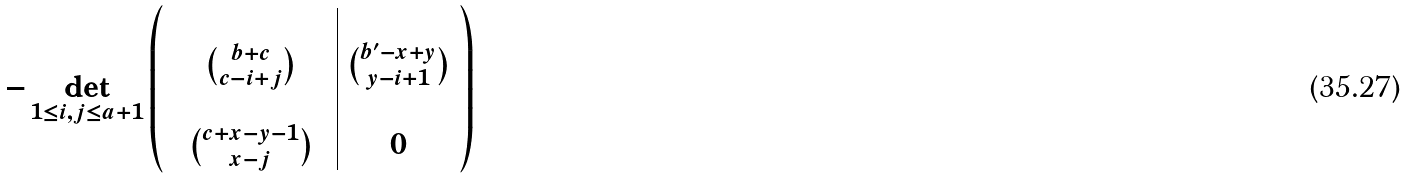Convert formula to latex. <formula><loc_0><loc_0><loc_500><loc_500>- \det _ { 1 \leq i , j \leq a + 1 } \left ( \begin{array} { c c c | c } & & & \\ & \binom { b + c } { c - i + j } & & \binom { b ^ { \prime } - x + y } { y - i + 1 } \\ & & & \\ & \binom { c + x - y - 1 } { x - j } & & 0 \end{array} \right )</formula> 